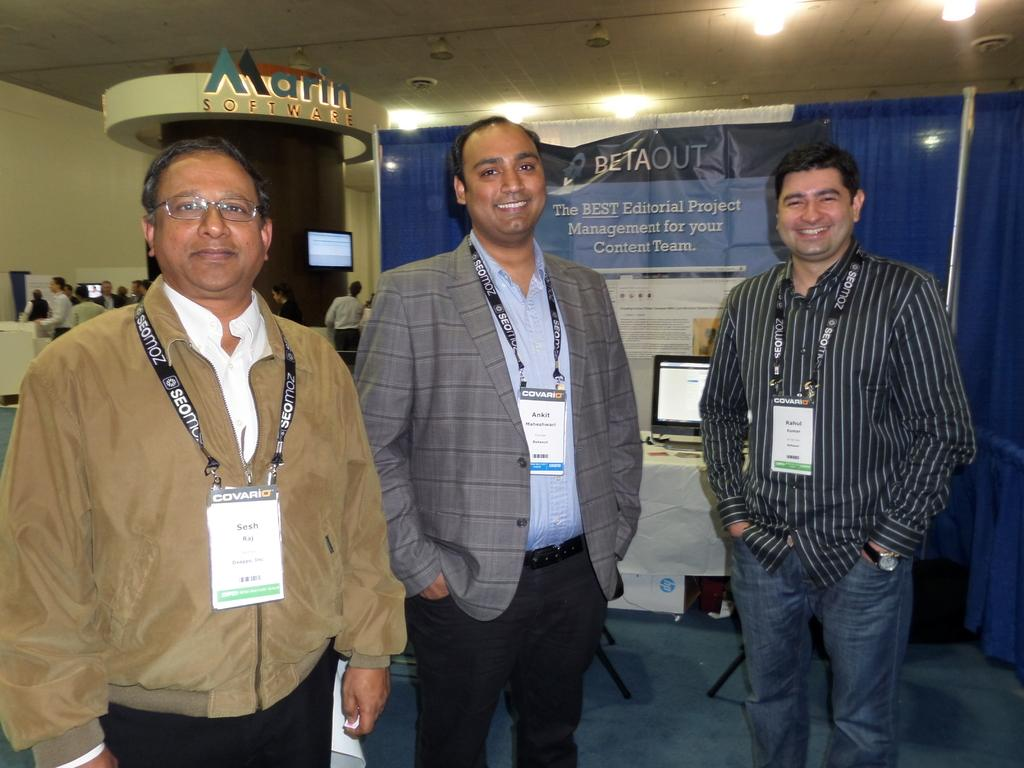How many people are in the image? There are three persons in the image. What are the persons wearing that can be seen in the image? The persons are wearing id cards. Where are the persons standing in the image? The persons are standing on the ground. What can be seen on a table in the background of the image? There is a monitor placed on a table in the background. What is happening in the background of the image? There is a group of people in the background. What type of salt is being used to control the weather in the image? There is no salt or weather control present in the image. What type of railway is visible in the image? There is no railway present in the image. 